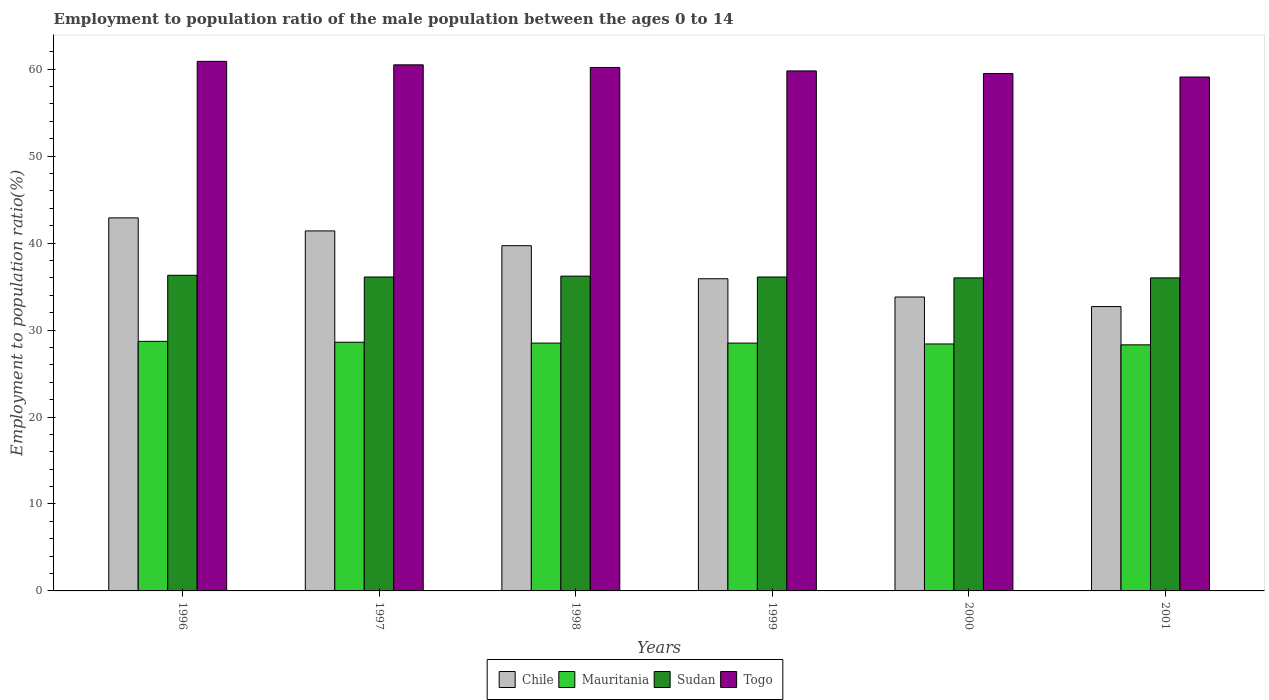Are the number of bars on each tick of the X-axis equal?
Offer a very short reply. Yes. What is the label of the 4th group of bars from the left?
Provide a succinct answer. 1999. In how many cases, is the number of bars for a given year not equal to the number of legend labels?
Your response must be concise. 0. What is the employment to population ratio in Chile in 1998?
Ensure brevity in your answer.  39.7. Across all years, what is the maximum employment to population ratio in Togo?
Give a very brief answer. 60.9. Across all years, what is the minimum employment to population ratio in Togo?
Make the answer very short. 59.1. In which year was the employment to population ratio in Togo minimum?
Your answer should be compact. 2001. What is the total employment to population ratio in Sudan in the graph?
Ensure brevity in your answer.  216.7. What is the difference between the employment to population ratio in Mauritania in 1997 and that in 1999?
Keep it short and to the point. 0.1. What is the difference between the employment to population ratio in Togo in 1998 and the employment to population ratio in Mauritania in 1997?
Offer a terse response. 31.6. What is the average employment to population ratio in Chile per year?
Your response must be concise. 37.73. In the year 1999, what is the difference between the employment to population ratio in Sudan and employment to population ratio in Chile?
Make the answer very short. 0.2. In how many years, is the employment to population ratio in Sudan greater than 36 %?
Your answer should be compact. 4. What is the ratio of the employment to population ratio in Chile in 1998 to that in 2001?
Your answer should be compact. 1.21. Is the difference between the employment to population ratio in Sudan in 1999 and 2000 greater than the difference between the employment to population ratio in Chile in 1999 and 2000?
Give a very brief answer. No. What is the difference between the highest and the second highest employment to population ratio in Chile?
Offer a terse response. 1.5. What is the difference between the highest and the lowest employment to population ratio in Mauritania?
Give a very brief answer. 0.4. Is the sum of the employment to population ratio in Sudan in 1996 and 2000 greater than the maximum employment to population ratio in Togo across all years?
Keep it short and to the point. Yes. What does the 1st bar from the left in 2000 represents?
Ensure brevity in your answer.  Chile. What does the 3rd bar from the right in 1996 represents?
Offer a terse response. Mauritania. Is it the case that in every year, the sum of the employment to population ratio in Chile and employment to population ratio in Mauritania is greater than the employment to population ratio in Sudan?
Provide a short and direct response. Yes. How many years are there in the graph?
Provide a short and direct response. 6. What is the difference between two consecutive major ticks on the Y-axis?
Provide a succinct answer. 10. Are the values on the major ticks of Y-axis written in scientific E-notation?
Provide a succinct answer. No. Does the graph contain any zero values?
Offer a very short reply. No. Does the graph contain grids?
Keep it short and to the point. No. How many legend labels are there?
Offer a terse response. 4. What is the title of the graph?
Provide a short and direct response. Employment to population ratio of the male population between the ages 0 to 14. Does "Argentina" appear as one of the legend labels in the graph?
Your response must be concise. No. What is the label or title of the Y-axis?
Ensure brevity in your answer.  Employment to population ratio(%). What is the Employment to population ratio(%) of Chile in 1996?
Offer a terse response. 42.9. What is the Employment to population ratio(%) in Mauritania in 1996?
Your response must be concise. 28.7. What is the Employment to population ratio(%) in Sudan in 1996?
Provide a short and direct response. 36.3. What is the Employment to population ratio(%) in Togo in 1996?
Ensure brevity in your answer.  60.9. What is the Employment to population ratio(%) of Chile in 1997?
Keep it short and to the point. 41.4. What is the Employment to population ratio(%) of Mauritania in 1997?
Give a very brief answer. 28.6. What is the Employment to population ratio(%) in Sudan in 1997?
Provide a short and direct response. 36.1. What is the Employment to population ratio(%) of Togo in 1997?
Your answer should be very brief. 60.5. What is the Employment to population ratio(%) in Chile in 1998?
Keep it short and to the point. 39.7. What is the Employment to population ratio(%) of Sudan in 1998?
Your response must be concise. 36.2. What is the Employment to population ratio(%) of Togo in 1998?
Offer a very short reply. 60.2. What is the Employment to population ratio(%) of Chile in 1999?
Provide a short and direct response. 35.9. What is the Employment to population ratio(%) in Sudan in 1999?
Your response must be concise. 36.1. What is the Employment to population ratio(%) of Togo in 1999?
Provide a succinct answer. 59.8. What is the Employment to population ratio(%) of Chile in 2000?
Keep it short and to the point. 33.8. What is the Employment to population ratio(%) in Mauritania in 2000?
Your response must be concise. 28.4. What is the Employment to population ratio(%) in Sudan in 2000?
Provide a short and direct response. 36. What is the Employment to population ratio(%) in Togo in 2000?
Your answer should be very brief. 59.5. What is the Employment to population ratio(%) in Chile in 2001?
Your answer should be compact. 32.7. What is the Employment to population ratio(%) of Mauritania in 2001?
Make the answer very short. 28.3. What is the Employment to population ratio(%) in Togo in 2001?
Ensure brevity in your answer.  59.1. Across all years, what is the maximum Employment to population ratio(%) in Chile?
Offer a very short reply. 42.9. Across all years, what is the maximum Employment to population ratio(%) of Mauritania?
Your answer should be compact. 28.7. Across all years, what is the maximum Employment to population ratio(%) of Sudan?
Ensure brevity in your answer.  36.3. Across all years, what is the maximum Employment to population ratio(%) of Togo?
Provide a succinct answer. 60.9. Across all years, what is the minimum Employment to population ratio(%) in Chile?
Keep it short and to the point. 32.7. Across all years, what is the minimum Employment to population ratio(%) in Mauritania?
Your answer should be very brief. 28.3. Across all years, what is the minimum Employment to population ratio(%) in Togo?
Make the answer very short. 59.1. What is the total Employment to population ratio(%) of Chile in the graph?
Give a very brief answer. 226.4. What is the total Employment to population ratio(%) of Mauritania in the graph?
Your answer should be compact. 171. What is the total Employment to population ratio(%) of Sudan in the graph?
Ensure brevity in your answer.  216.7. What is the total Employment to population ratio(%) in Togo in the graph?
Keep it short and to the point. 360. What is the difference between the Employment to population ratio(%) in Chile in 1996 and that in 1997?
Provide a short and direct response. 1.5. What is the difference between the Employment to population ratio(%) of Mauritania in 1996 and that in 1997?
Your answer should be compact. 0.1. What is the difference between the Employment to population ratio(%) in Sudan in 1996 and that in 1997?
Keep it short and to the point. 0.2. What is the difference between the Employment to population ratio(%) of Chile in 1996 and that in 1998?
Give a very brief answer. 3.2. What is the difference between the Employment to population ratio(%) in Togo in 1996 and that in 1998?
Your answer should be compact. 0.7. What is the difference between the Employment to population ratio(%) in Chile in 1996 and that in 1999?
Your answer should be very brief. 7. What is the difference between the Employment to population ratio(%) in Mauritania in 1996 and that in 2000?
Your response must be concise. 0.3. What is the difference between the Employment to population ratio(%) of Sudan in 1996 and that in 2000?
Keep it short and to the point. 0.3. What is the difference between the Employment to population ratio(%) in Togo in 1996 and that in 2000?
Make the answer very short. 1.4. What is the difference between the Employment to population ratio(%) of Mauritania in 1996 and that in 2001?
Your response must be concise. 0.4. What is the difference between the Employment to population ratio(%) in Sudan in 1996 and that in 2001?
Your answer should be compact. 0.3. What is the difference between the Employment to population ratio(%) of Chile in 1997 and that in 1998?
Offer a terse response. 1.7. What is the difference between the Employment to population ratio(%) in Mauritania in 1997 and that in 1998?
Keep it short and to the point. 0.1. What is the difference between the Employment to population ratio(%) in Chile in 1997 and that in 1999?
Your answer should be very brief. 5.5. What is the difference between the Employment to population ratio(%) in Mauritania in 1997 and that in 1999?
Your answer should be compact. 0.1. What is the difference between the Employment to population ratio(%) in Sudan in 1997 and that in 1999?
Offer a terse response. 0. What is the difference between the Employment to population ratio(%) in Mauritania in 1997 and that in 2000?
Offer a terse response. 0.2. What is the difference between the Employment to population ratio(%) in Mauritania in 1997 and that in 2001?
Offer a very short reply. 0.3. What is the difference between the Employment to population ratio(%) of Sudan in 1997 and that in 2001?
Offer a terse response. 0.1. What is the difference between the Employment to population ratio(%) of Togo in 1997 and that in 2001?
Provide a succinct answer. 1.4. What is the difference between the Employment to population ratio(%) in Mauritania in 1998 and that in 1999?
Give a very brief answer. 0. What is the difference between the Employment to population ratio(%) in Sudan in 1998 and that in 1999?
Your answer should be compact. 0.1. What is the difference between the Employment to population ratio(%) in Chile in 1998 and that in 2000?
Make the answer very short. 5.9. What is the difference between the Employment to population ratio(%) in Mauritania in 1998 and that in 2000?
Your answer should be very brief. 0.1. What is the difference between the Employment to population ratio(%) in Togo in 1998 and that in 2000?
Your response must be concise. 0.7. What is the difference between the Employment to population ratio(%) of Chile in 1998 and that in 2001?
Offer a very short reply. 7. What is the difference between the Employment to population ratio(%) of Mauritania in 1998 and that in 2001?
Offer a very short reply. 0.2. What is the difference between the Employment to population ratio(%) of Togo in 1998 and that in 2001?
Make the answer very short. 1.1. What is the difference between the Employment to population ratio(%) in Chile in 1999 and that in 2000?
Give a very brief answer. 2.1. What is the difference between the Employment to population ratio(%) of Togo in 1999 and that in 2000?
Your answer should be compact. 0.3. What is the difference between the Employment to population ratio(%) in Togo in 1999 and that in 2001?
Keep it short and to the point. 0.7. What is the difference between the Employment to population ratio(%) of Chile in 2000 and that in 2001?
Give a very brief answer. 1.1. What is the difference between the Employment to population ratio(%) of Togo in 2000 and that in 2001?
Provide a succinct answer. 0.4. What is the difference between the Employment to population ratio(%) of Chile in 1996 and the Employment to population ratio(%) of Sudan in 1997?
Provide a short and direct response. 6.8. What is the difference between the Employment to population ratio(%) of Chile in 1996 and the Employment to population ratio(%) of Togo in 1997?
Ensure brevity in your answer.  -17.6. What is the difference between the Employment to population ratio(%) of Mauritania in 1996 and the Employment to population ratio(%) of Togo in 1997?
Provide a short and direct response. -31.8. What is the difference between the Employment to population ratio(%) in Sudan in 1996 and the Employment to population ratio(%) in Togo in 1997?
Your answer should be very brief. -24.2. What is the difference between the Employment to population ratio(%) of Chile in 1996 and the Employment to population ratio(%) of Mauritania in 1998?
Provide a succinct answer. 14.4. What is the difference between the Employment to population ratio(%) in Chile in 1996 and the Employment to population ratio(%) in Sudan in 1998?
Your response must be concise. 6.7. What is the difference between the Employment to population ratio(%) in Chile in 1996 and the Employment to population ratio(%) in Togo in 1998?
Give a very brief answer. -17.3. What is the difference between the Employment to population ratio(%) in Mauritania in 1996 and the Employment to population ratio(%) in Sudan in 1998?
Offer a very short reply. -7.5. What is the difference between the Employment to population ratio(%) of Mauritania in 1996 and the Employment to population ratio(%) of Togo in 1998?
Keep it short and to the point. -31.5. What is the difference between the Employment to population ratio(%) of Sudan in 1996 and the Employment to population ratio(%) of Togo in 1998?
Your response must be concise. -23.9. What is the difference between the Employment to population ratio(%) in Chile in 1996 and the Employment to population ratio(%) in Mauritania in 1999?
Your answer should be very brief. 14.4. What is the difference between the Employment to population ratio(%) in Chile in 1996 and the Employment to population ratio(%) in Sudan in 1999?
Keep it short and to the point. 6.8. What is the difference between the Employment to population ratio(%) of Chile in 1996 and the Employment to population ratio(%) of Togo in 1999?
Provide a succinct answer. -16.9. What is the difference between the Employment to population ratio(%) of Mauritania in 1996 and the Employment to population ratio(%) of Sudan in 1999?
Offer a very short reply. -7.4. What is the difference between the Employment to population ratio(%) in Mauritania in 1996 and the Employment to population ratio(%) in Togo in 1999?
Offer a terse response. -31.1. What is the difference between the Employment to population ratio(%) in Sudan in 1996 and the Employment to population ratio(%) in Togo in 1999?
Provide a short and direct response. -23.5. What is the difference between the Employment to population ratio(%) of Chile in 1996 and the Employment to population ratio(%) of Mauritania in 2000?
Provide a short and direct response. 14.5. What is the difference between the Employment to population ratio(%) of Chile in 1996 and the Employment to population ratio(%) of Sudan in 2000?
Offer a very short reply. 6.9. What is the difference between the Employment to population ratio(%) of Chile in 1996 and the Employment to population ratio(%) of Togo in 2000?
Your answer should be very brief. -16.6. What is the difference between the Employment to population ratio(%) of Mauritania in 1996 and the Employment to population ratio(%) of Sudan in 2000?
Provide a succinct answer. -7.3. What is the difference between the Employment to population ratio(%) of Mauritania in 1996 and the Employment to population ratio(%) of Togo in 2000?
Your answer should be compact. -30.8. What is the difference between the Employment to population ratio(%) in Sudan in 1996 and the Employment to population ratio(%) in Togo in 2000?
Offer a very short reply. -23.2. What is the difference between the Employment to population ratio(%) in Chile in 1996 and the Employment to population ratio(%) in Mauritania in 2001?
Your response must be concise. 14.6. What is the difference between the Employment to population ratio(%) of Chile in 1996 and the Employment to population ratio(%) of Togo in 2001?
Make the answer very short. -16.2. What is the difference between the Employment to population ratio(%) in Mauritania in 1996 and the Employment to population ratio(%) in Togo in 2001?
Offer a very short reply. -30.4. What is the difference between the Employment to population ratio(%) in Sudan in 1996 and the Employment to population ratio(%) in Togo in 2001?
Keep it short and to the point. -22.8. What is the difference between the Employment to population ratio(%) of Chile in 1997 and the Employment to population ratio(%) of Mauritania in 1998?
Make the answer very short. 12.9. What is the difference between the Employment to population ratio(%) of Chile in 1997 and the Employment to population ratio(%) of Togo in 1998?
Make the answer very short. -18.8. What is the difference between the Employment to population ratio(%) of Mauritania in 1997 and the Employment to population ratio(%) of Togo in 1998?
Your answer should be very brief. -31.6. What is the difference between the Employment to population ratio(%) in Sudan in 1997 and the Employment to population ratio(%) in Togo in 1998?
Your answer should be compact. -24.1. What is the difference between the Employment to population ratio(%) in Chile in 1997 and the Employment to population ratio(%) in Mauritania in 1999?
Your answer should be compact. 12.9. What is the difference between the Employment to population ratio(%) in Chile in 1997 and the Employment to population ratio(%) in Sudan in 1999?
Offer a very short reply. 5.3. What is the difference between the Employment to population ratio(%) of Chile in 1997 and the Employment to population ratio(%) of Togo in 1999?
Your answer should be very brief. -18.4. What is the difference between the Employment to population ratio(%) in Mauritania in 1997 and the Employment to population ratio(%) in Sudan in 1999?
Offer a terse response. -7.5. What is the difference between the Employment to population ratio(%) of Mauritania in 1997 and the Employment to population ratio(%) of Togo in 1999?
Keep it short and to the point. -31.2. What is the difference between the Employment to population ratio(%) of Sudan in 1997 and the Employment to population ratio(%) of Togo in 1999?
Your answer should be compact. -23.7. What is the difference between the Employment to population ratio(%) in Chile in 1997 and the Employment to population ratio(%) in Togo in 2000?
Give a very brief answer. -18.1. What is the difference between the Employment to population ratio(%) in Mauritania in 1997 and the Employment to population ratio(%) in Sudan in 2000?
Your answer should be very brief. -7.4. What is the difference between the Employment to population ratio(%) in Mauritania in 1997 and the Employment to population ratio(%) in Togo in 2000?
Offer a very short reply. -30.9. What is the difference between the Employment to population ratio(%) in Sudan in 1997 and the Employment to population ratio(%) in Togo in 2000?
Keep it short and to the point. -23.4. What is the difference between the Employment to population ratio(%) of Chile in 1997 and the Employment to population ratio(%) of Sudan in 2001?
Your response must be concise. 5.4. What is the difference between the Employment to population ratio(%) in Chile in 1997 and the Employment to population ratio(%) in Togo in 2001?
Ensure brevity in your answer.  -17.7. What is the difference between the Employment to population ratio(%) in Mauritania in 1997 and the Employment to population ratio(%) in Togo in 2001?
Provide a short and direct response. -30.5. What is the difference between the Employment to population ratio(%) of Chile in 1998 and the Employment to population ratio(%) of Togo in 1999?
Provide a short and direct response. -20.1. What is the difference between the Employment to population ratio(%) of Mauritania in 1998 and the Employment to population ratio(%) of Sudan in 1999?
Make the answer very short. -7.6. What is the difference between the Employment to population ratio(%) of Mauritania in 1998 and the Employment to population ratio(%) of Togo in 1999?
Make the answer very short. -31.3. What is the difference between the Employment to population ratio(%) in Sudan in 1998 and the Employment to population ratio(%) in Togo in 1999?
Your answer should be very brief. -23.6. What is the difference between the Employment to population ratio(%) of Chile in 1998 and the Employment to population ratio(%) of Togo in 2000?
Ensure brevity in your answer.  -19.8. What is the difference between the Employment to population ratio(%) of Mauritania in 1998 and the Employment to population ratio(%) of Sudan in 2000?
Ensure brevity in your answer.  -7.5. What is the difference between the Employment to population ratio(%) of Mauritania in 1998 and the Employment to population ratio(%) of Togo in 2000?
Give a very brief answer. -31. What is the difference between the Employment to population ratio(%) of Sudan in 1998 and the Employment to population ratio(%) of Togo in 2000?
Offer a terse response. -23.3. What is the difference between the Employment to population ratio(%) of Chile in 1998 and the Employment to population ratio(%) of Sudan in 2001?
Make the answer very short. 3.7. What is the difference between the Employment to population ratio(%) of Chile in 1998 and the Employment to population ratio(%) of Togo in 2001?
Your answer should be very brief. -19.4. What is the difference between the Employment to population ratio(%) in Mauritania in 1998 and the Employment to population ratio(%) in Togo in 2001?
Give a very brief answer. -30.6. What is the difference between the Employment to population ratio(%) of Sudan in 1998 and the Employment to population ratio(%) of Togo in 2001?
Your answer should be very brief. -22.9. What is the difference between the Employment to population ratio(%) in Chile in 1999 and the Employment to population ratio(%) in Mauritania in 2000?
Keep it short and to the point. 7.5. What is the difference between the Employment to population ratio(%) in Chile in 1999 and the Employment to population ratio(%) in Sudan in 2000?
Make the answer very short. -0.1. What is the difference between the Employment to population ratio(%) of Chile in 1999 and the Employment to population ratio(%) of Togo in 2000?
Your answer should be compact. -23.6. What is the difference between the Employment to population ratio(%) of Mauritania in 1999 and the Employment to population ratio(%) of Togo in 2000?
Offer a very short reply. -31. What is the difference between the Employment to population ratio(%) of Sudan in 1999 and the Employment to population ratio(%) of Togo in 2000?
Your answer should be compact. -23.4. What is the difference between the Employment to population ratio(%) of Chile in 1999 and the Employment to population ratio(%) of Togo in 2001?
Provide a succinct answer. -23.2. What is the difference between the Employment to population ratio(%) in Mauritania in 1999 and the Employment to population ratio(%) in Sudan in 2001?
Offer a terse response. -7.5. What is the difference between the Employment to population ratio(%) of Mauritania in 1999 and the Employment to population ratio(%) of Togo in 2001?
Offer a very short reply. -30.6. What is the difference between the Employment to population ratio(%) of Sudan in 1999 and the Employment to population ratio(%) of Togo in 2001?
Keep it short and to the point. -23. What is the difference between the Employment to population ratio(%) in Chile in 2000 and the Employment to population ratio(%) in Togo in 2001?
Your answer should be very brief. -25.3. What is the difference between the Employment to population ratio(%) of Mauritania in 2000 and the Employment to population ratio(%) of Sudan in 2001?
Provide a short and direct response. -7.6. What is the difference between the Employment to population ratio(%) in Mauritania in 2000 and the Employment to population ratio(%) in Togo in 2001?
Your answer should be very brief. -30.7. What is the difference between the Employment to population ratio(%) in Sudan in 2000 and the Employment to population ratio(%) in Togo in 2001?
Give a very brief answer. -23.1. What is the average Employment to population ratio(%) in Chile per year?
Your answer should be compact. 37.73. What is the average Employment to population ratio(%) in Sudan per year?
Offer a very short reply. 36.12. In the year 1996, what is the difference between the Employment to population ratio(%) of Chile and Employment to population ratio(%) of Sudan?
Your answer should be very brief. 6.6. In the year 1996, what is the difference between the Employment to population ratio(%) of Mauritania and Employment to population ratio(%) of Sudan?
Provide a short and direct response. -7.6. In the year 1996, what is the difference between the Employment to population ratio(%) of Mauritania and Employment to population ratio(%) of Togo?
Offer a terse response. -32.2. In the year 1996, what is the difference between the Employment to population ratio(%) in Sudan and Employment to population ratio(%) in Togo?
Provide a succinct answer. -24.6. In the year 1997, what is the difference between the Employment to population ratio(%) of Chile and Employment to population ratio(%) of Togo?
Keep it short and to the point. -19.1. In the year 1997, what is the difference between the Employment to population ratio(%) of Mauritania and Employment to population ratio(%) of Sudan?
Provide a succinct answer. -7.5. In the year 1997, what is the difference between the Employment to population ratio(%) in Mauritania and Employment to population ratio(%) in Togo?
Your answer should be compact. -31.9. In the year 1997, what is the difference between the Employment to population ratio(%) in Sudan and Employment to population ratio(%) in Togo?
Offer a terse response. -24.4. In the year 1998, what is the difference between the Employment to population ratio(%) of Chile and Employment to population ratio(%) of Mauritania?
Your answer should be compact. 11.2. In the year 1998, what is the difference between the Employment to population ratio(%) in Chile and Employment to population ratio(%) in Togo?
Ensure brevity in your answer.  -20.5. In the year 1998, what is the difference between the Employment to population ratio(%) of Mauritania and Employment to population ratio(%) of Sudan?
Offer a terse response. -7.7. In the year 1998, what is the difference between the Employment to population ratio(%) of Mauritania and Employment to population ratio(%) of Togo?
Provide a short and direct response. -31.7. In the year 1999, what is the difference between the Employment to population ratio(%) of Chile and Employment to population ratio(%) of Togo?
Make the answer very short. -23.9. In the year 1999, what is the difference between the Employment to population ratio(%) in Mauritania and Employment to population ratio(%) in Sudan?
Your response must be concise. -7.6. In the year 1999, what is the difference between the Employment to population ratio(%) in Mauritania and Employment to population ratio(%) in Togo?
Your response must be concise. -31.3. In the year 1999, what is the difference between the Employment to population ratio(%) of Sudan and Employment to population ratio(%) of Togo?
Provide a short and direct response. -23.7. In the year 2000, what is the difference between the Employment to population ratio(%) in Chile and Employment to population ratio(%) in Togo?
Your answer should be compact. -25.7. In the year 2000, what is the difference between the Employment to population ratio(%) of Mauritania and Employment to population ratio(%) of Sudan?
Make the answer very short. -7.6. In the year 2000, what is the difference between the Employment to population ratio(%) in Mauritania and Employment to population ratio(%) in Togo?
Your answer should be very brief. -31.1. In the year 2000, what is the difference between the Employment to population ratio(%) in Sudan and Employment to population ratio(%) in Togo?
Make the answer very short. -23.5. In the year 2001, what is the difference between the Employment to population ratio(%) of Chile and Employment to population ratio(%) of Mauritania?
Give a very brief answer. 4.4. In the year 2001, what is the difference between the Employment to population ratio(%) in Chile and Employment to population ratio(%) in Togo?
Ensure brevity in your answer.  -26.4. In the year 2001, what is the difference between the Employment to population ratio(%) of Mauritania and Employment to population ratio(%) of Togo?
Your answer should be very brief. -30.8. In the year 2001, what is the difference between the Employment to population ratio(%) of Sudan and Employment to population ratio(%) of Togo?
Your answer should be compact. -23.1. What is the ratio of the Employment to population ratio(%) in Chile in 1996 to that in 1997?
Offer a terse response. 1.04. What is the ratio of the Employment to population ratio(%) of Mauritania in 1996 to that in 1997?
Offer a terse response. 1. What is the ratio of the Employment to population ratio(%) of Sudan in 1996 to that in 1997?
Your answer should be very brief. 1.01. What is the ratio of the Employment to population ratio(%) in Togo in 1996 to that in 1997?
Make the answer very short. 1.01. What is the ratio of the Employment to population ratio(%) of Chile in 1996 to that in 1998?
Make the answer very short. 1.08. What is the ratio of the Employment to population ratio(%) in Mauritania in 1996 to that in 1998?
Provide a short and direct response. 1.01. What is the ratio of the Employment to population ratio(%) in Togo in 1996 to that in 1998?
Make the answer very short. 1.01. What is the ratio of the Employment to population ratio(%) of Chile in 1996 to that in 1999?
Offer a very short reply. 1.2. What is the ratio of the Employment to population ratio(%) of Togo in 1996 to that in 1999?
Keep it short and to the point. 1.02. What is the ratio of the Employment to population ratio(%) of Chile in 1996 to that in 2000?
Your answer should be very brief. 1.27. What is the ratio of the Employment to population ratio(%) in Mauritania in 1996 to that in 2000?
Your answer should be very brief. 1.01. What is the ratio of the Employment to population ratio(%) of Sudan in 1996 to that in 2000?
Offer a very short reply. 1.01. What is the ratio of the Employment to population ratio(%) in Togo in 1996 to that in 2000?
Provide a succinct answer. 1.02. What is the ratio of the Employment to population ratio(%) of Chile in 1996 to that in 2001?
Provide a succinct answer. 1.31. What is the ratio of the Employment to population ratio(%) of Mauritania in 1996 to that in 2001?
Ensure brevity in your answer.  1.01. What is the ratio of the Employment to population ratio(%) in Sudan in 1996 to that in 2001?
Keep it short and to the point. 1.01. What is the ratio of the Employment to population ratio(%) of Togo in 1996 to that in 2001?
Provide a succinct answer. 1.03. What is the ratio of the Employment to population ratio(%) of Chile in 1997 to that in 1998?
Provide a succinct answer. 1.04. What is the ratio of the Employment to population ratio(%) of Mauritania in 1997 to that in 1998?
Your answer should be compact. 1. What is the ratio of the Employment to population ratio(%) in Togo in 1997 to that in 1998?
Offer a very short reply. 1. What is the ratio of the Employment to population ratio(%) in Chile in 1997 to that in 1999?
Offer a terse response. 1.15. What is the ratio of the Employment to population ratio(%) in Togo in 1997 to that in 1999?
Offer a very short reply. 1.01. What is the ratio of the Employment to population ratio(%) of Chile in 1997 to that in 2000?
Provide a succinct answer. 1.22. What is the ratio of the Employment to population ratio(%) of Mauritania in 1997 to that in 2000?
Ensure brevity in your answer.  1.01. What is the ratio of the Employment to population ratio(%) of Togo in 1997 to that in 2000?
Ensure brevity in your answer.  1.02. What is the ratio of the Employment to population ratio(%) of Chile in 1997 to that in 2001?
Provide a succinct answer. 1.27. What is the ratio of the Employment to population ratio(%) of Mauritania in 1997 to that in 2001?
Keep it short and to the point. 1.01. What is the ratio of the Employment to population ratio(%) of Togo in 1997 to that in 2001?
Make the answer very short. 1.02. What is the ratio of the Employment to population ratio(%) of Chile in 1998 to that in 1999?
Make the answer very short. 1.11. What is the ratio of the Employment to population ratio(%) of Mauritania in 1998 to that in 1999?
Offer a very short reply. 1. What is the ratio of the Employment to population ratio(%) in Sudan in 1998 to that in 1999?
Offer a terse response. 1. What is the ratio of the Employment to population ratio(%) in Chile in 1998 to that in 2000?
Provide a succinct answer. 1.17. What is the ratio of the Employment to population ratio(%) of Sudan in 1998 to that in 2000?
Your answer should be very brief. 1.01. What is the ratio of the Employment to population ratio(%) in Togo in 1998 to that in 2000?
Your answer should be very brief. 1.01. What is the ratio of the Employment to population ratio(%) in Chile in 1998 to that in 2001?
Your answer should be compact. 1.21. What is the ratio of the Employment to population ratio(%) in Mauritania in 1998 to that in 2001?
Provide a succinct answer. 1.01. What is the ratio of the Employment to population ratio(%) of Sudan in 1998 to that in 2001?
Your answer should be compact. 1.01. What is the ratio of the Employment to population ratio(%) in Togo in 1998 to that in 2001?
Ensure brevity in your answer.  1.02. What is the ratio of the Employment to population ratio(%) in Chile in 1999 to that in 2000?
Offer a very short reply. 1.06. What is the ratio of the Employment to population ratio(%) of Mauritania in 1999 to that in 2000?
Offer a very short reply. 1. What is the ratio of the Employment to population ratio(%) of Sudan in 1999 to that in 2000?
Keep it short and to the point. 1. What is the ratio of the Employment to population ratio(%) of Chile in 1999 to that in 2001?
Your response must be concise. 1.1. What is the ratio of the Employment to population ratio(%) in Mauritania in 1999 to that in 2001?
Offer a very short reply. 1.01. What is the ratio of the Employment to population ratio(%) of Togo in 1999 to that in 2001?
Keep it short and to the point. 1.01. What is the ratio of the Employment to population ratio(%) in Chile in 2000 to that in 2001?
Ensure brevity in your answer.  1.03. What is the ratio of the Employment to population ratio(%) in Sudan in 2000 to that in 2001?
Your answer should be very brief. 1. What is the ratio of the Employment to population ratio(%) in Togo in 2000 to that in 2001?
Offer a terse response. 1.01. What is the difference between the highest and the second highest Employment to population ratio(%) in Chile?
Give a very brief answer. 1.5. 